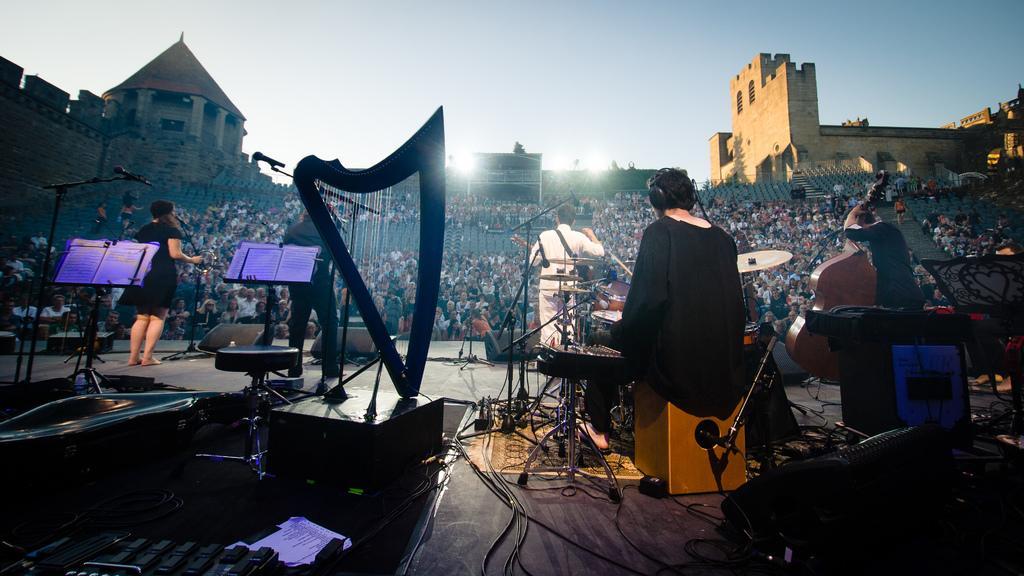Can you describe this image briefly? In this picture we can see some people playing musical instruments, mics, stool, wires, stands and these all are on stage and in front of this stage we can see a group of people sitting on chairs, buildings and in the background we can see the sky. 